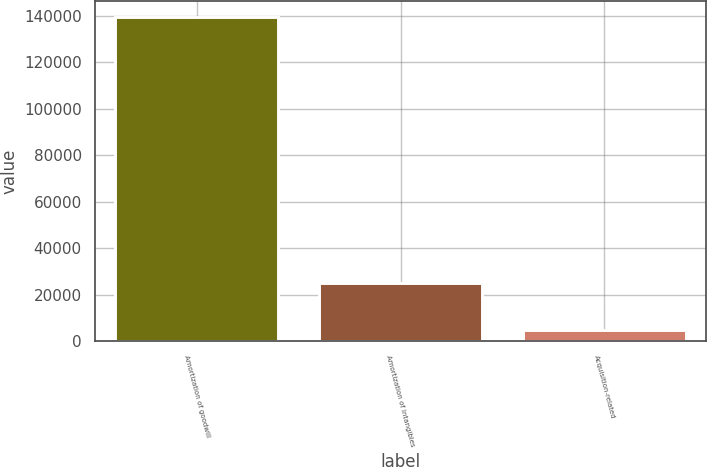<chart> <loc_0><loc_0><loc_500><loc_500><bar_chart><fcel>Amortization of goodwill<fcel>Amortization of intangibles<fcel>Acquisition-related<nl><fcel>139455<fcel>25022<fcel>4938<nl></chart> 